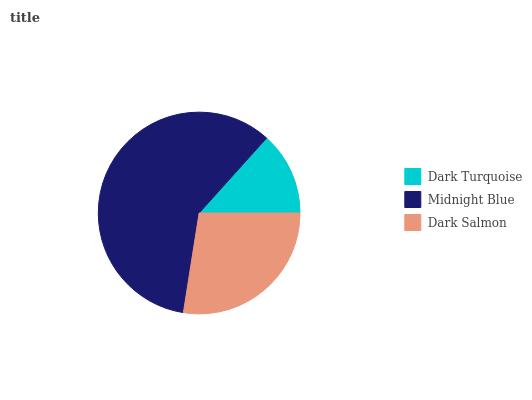Is Dark Turquoise the minimum?
Answer yes or no. Yes. Is Midnight Blue the maximum?
Answer yes or no. Yes. Is Dark Salmon the minimum?
Answer yes or no. No. Is Dark Salmon the maximum?
Answer yes or no. No. Is Midnight Blue greater than Dark Salmon?
Answer yes or no. Yes. Is Dark Salmon less than Midnight Blue?
Answer yes or no. Yes. Is Dark Salmon greater than Midnight Blue?
Answer yes or no. No. Is Midnight Blue less than Dark Salmon?
Answer yes or no. No. Is Dark Salmon the high median?
Answer yes or no. Yes. Is Dark Salmon the low median?
Answer yes or no. Yes. Is Midnight Blue the high median?
Answer yes or no. No. Is Dark Turquoise the low median?
Answer yes or no. No. 